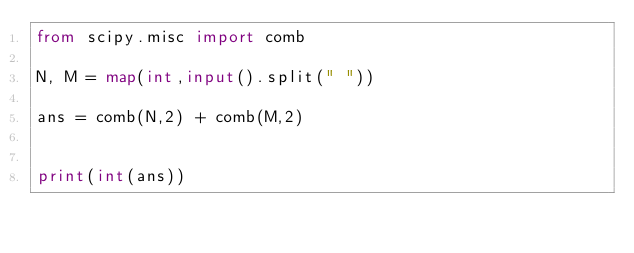Convert code to text. <code><loc_0><loc_0><loc_500><loc_500><_Python_>from scipy.misc import comb

N, M = map(int,input().split(" "))

ans = comb(N,2) + comb(M,2)


print(int(ans))</code> 